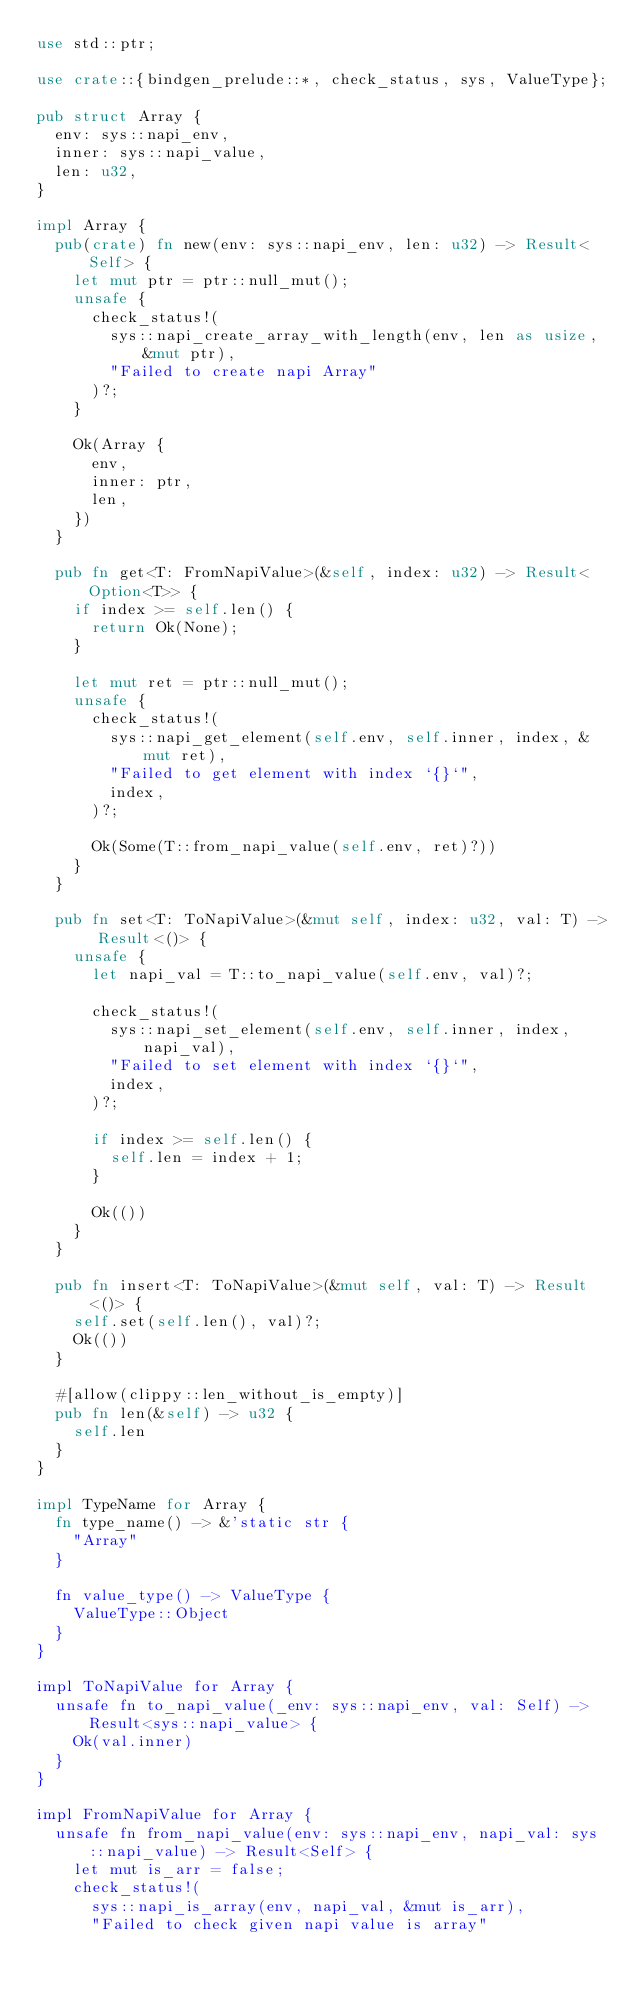Convert code to text. <code><loc_0><loc_0><loc_500><loc_500><_Rust_>use std::ptr;

use crate::{bindgen_prelude::*, check_status, sys, ValueType};

pub struct Array {
  env: sys::napi_env,
  inner: sys::napi_value,
  len: u32,
}

impl Array {
  pub(crate) fn new(env: sys::napi_env, len: u32) -> Result<Self> {
    let mut ptr = ptr::null_mut();
    unsafe {
      check_status!(
        sys::napi_create_array_with_length(env, len as usize, &mut ptr),
        "Failed to create napi Array"
      )?;
    }

    Ok(Array {
      env,
      inner: ptr,
      len,
    })
  }

  pub fn get<T: FromNapiValue>(&self, index: u32) -> Result<Option<T>> {
    if index >= self.len() {
      return Ok(None);
    }

    let mut ret = ptr::null_mut();
    unsafe {
      check_status!(
        sys::napi_get_element(self.env, self.inner, index, &mut ret),
        "Failed to get element with index `{}`",
        index,
      )?;

      Ok(Some(T::from_napi_value(self.env, ret)?))
    }
  }

  pub fn set<T: ToNapiValue>(&mut self, index: u32, val: T) -> Result<()> {
    unsafe {
      let napi_val = T::to_napi_value(self.env, val)?;

      check_status!(
        sys::napi_set_element(self.env, self.inner, index, napi_val),
        "Failed to set element with index `{}`",
        index,
      )?;

      if index >= self.len() {
        self.len = index + 1;
      }

      Ok(())
    }
  }

  pub fn insert<T: ToNapiValue>(&mut self, val: T) -> Result<()> {
    self.set(self.len(), val)?;
    Ok(())
  }

  #[allow(clippy::len_without_is_empty)]
  pub fn len(&self) -> u32 {
    self.len
  }
}

impl TypeName for Array {
  fn type_name() -> &'static str {
    "Array"
  }

  fn value_type() -> ValueType {
    ValueType::Object
  }
}

impl ToNapiValue for Array {
  unsafe fn to_napi_value(_env: sys::napi_env, val: Self) -> Result<sys::napi_value> {
    Ok(val.inner)
  }
}

impl FromNapiValue for Array {
  unsafe fn from_napi_value(env: sys::napi_env, napi_val: sys::napi_value) -> Result<Self> {
    let mut is_arr = false;
    check_status!(
      sys::napi_is_array(env, napi_val, &mut is_arr),
      "Failed to check given napi value is array"</code> 